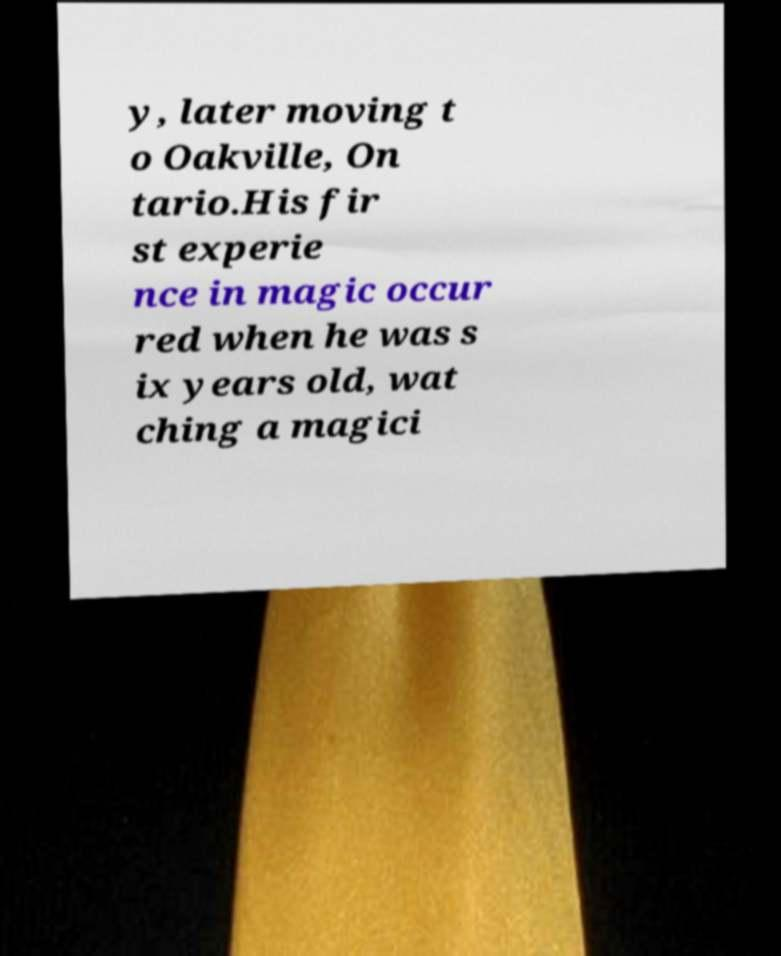Please read and relay the text visible in this image. What does it say? y, later moving t o Oakville, On tario.His fir st experie nce in magic occur red when he was s ix years old, wat ching a magici 